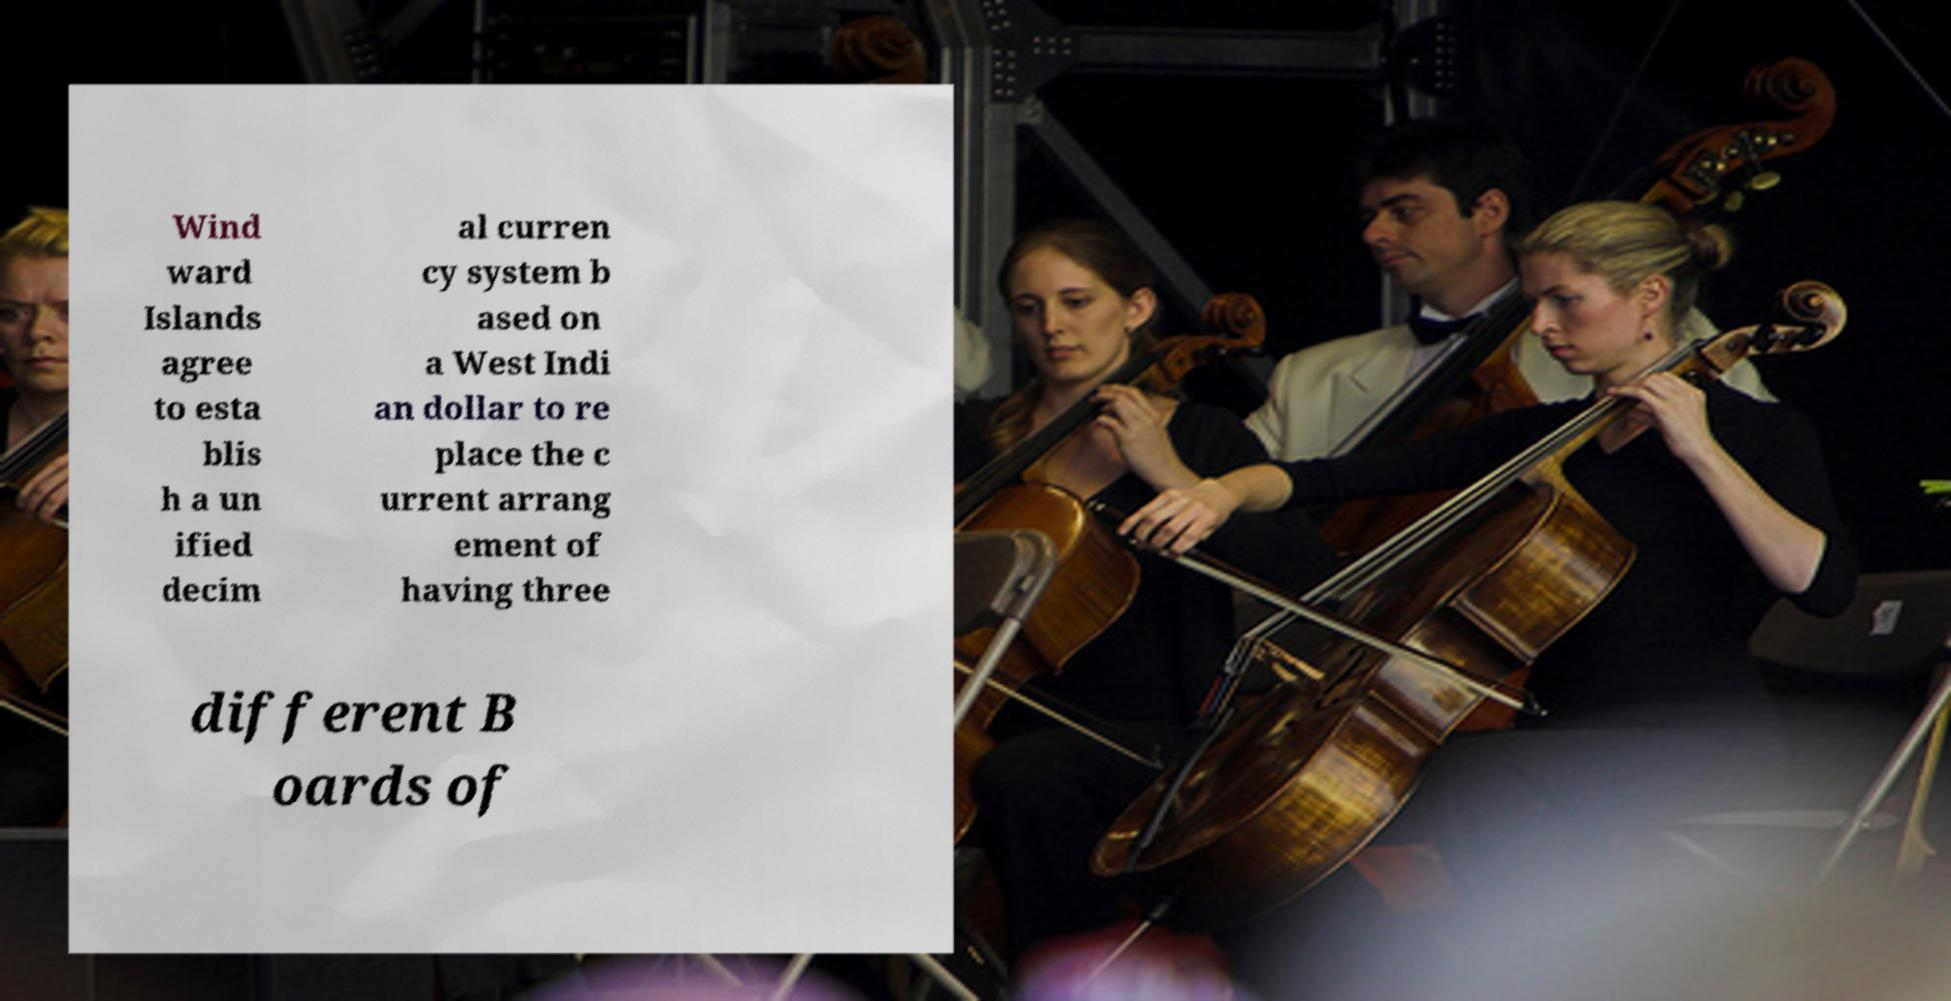Can you accurately transcribe the text from the provided image for me? Wind ward Islands agree to esta blis h a un ified decim al curren cy system b ased on a West Indi an dollar to re place the c urrent arrang ement of having three different B oards of 